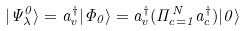Convert formula to latex. <formula><loc_0><loc_0><loc_500><loc_500>| \Psi ^ { 0 } _ { \lambda } \rangle = a ^ { \dagger } _ { v } | \Phi _ { 0 } \rangle = a ^ { \dagger } _ { v } ( \Pi _ { c = 1 } ^ { N } a _ { c } ^ { \dagger } ) | 0 \rangle</formula> 